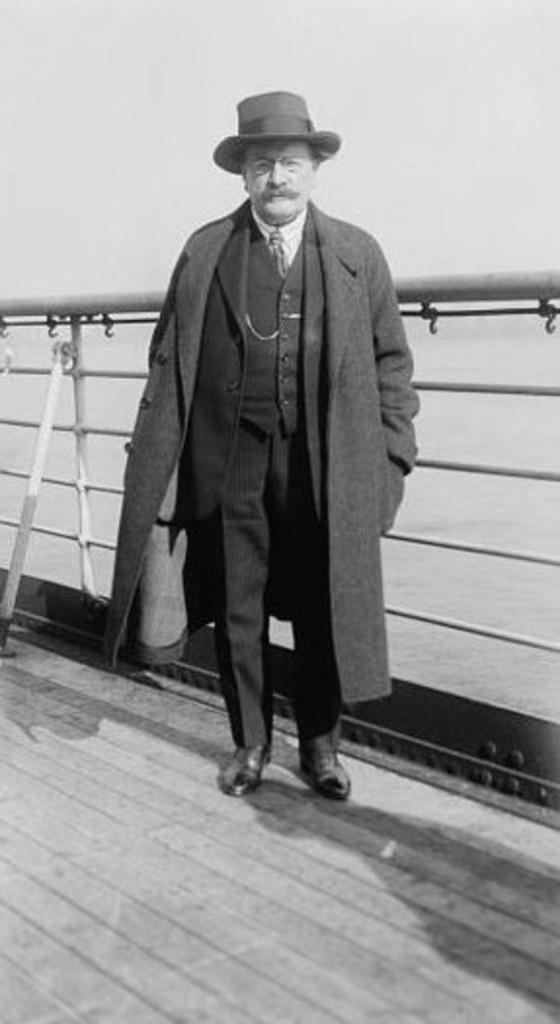Describe this image in one or two sentences. In this image I can see an old photograph in which I can see a person is standing on the wooden surface and the railing behind him. In the background I can see the water and the sky. 